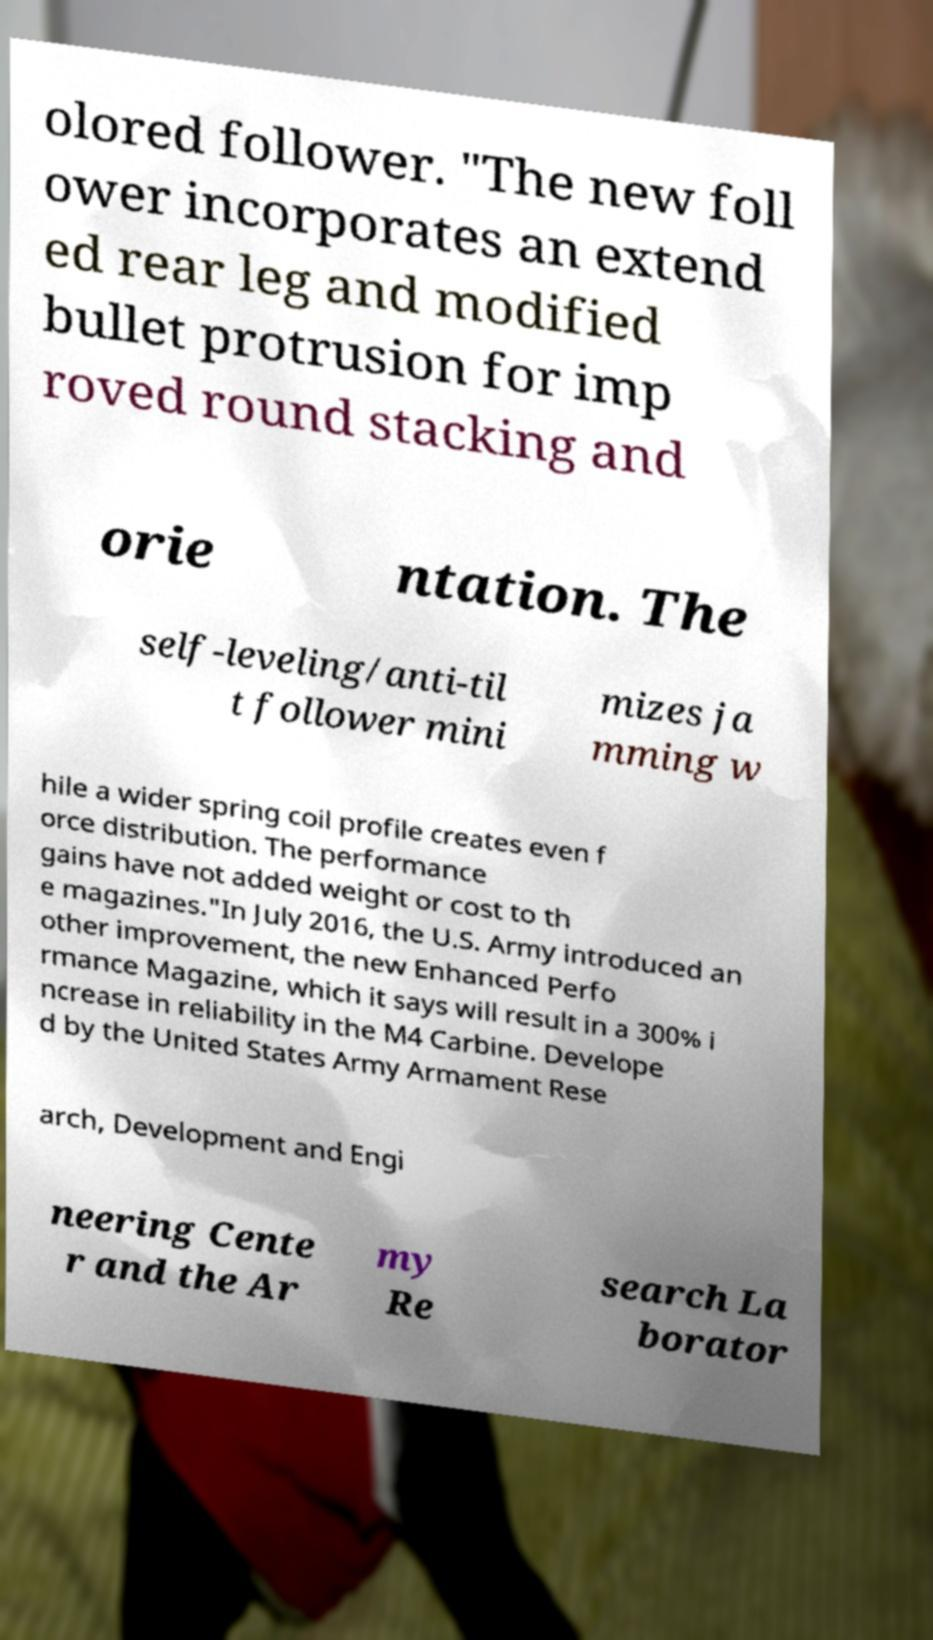Can you read and provide the text displayed in the image?This photo seems to have some interesting text. Can you extract and type it out for me? olored follower. "The new foll ower incorporates an extend ed rear leg and modified bullet protrusion for imp roved round stacking and orie ntation. The self-leveling/anti-til t follower mini mizes ja mming w hile a wider spring coil profile creates even f orce distribution. The performance gains have not added weight or cost to th e magazines."In July 2016, the U.S. Army introduced an other improvement, the new Enhanced Perfo rmance Magazine, which it says will result in a 300% i ncrease in reliability in the M4 Carbine. Develope d by the United States Army Armament Rese arch, Development and Engi neering Cente r and the Ar my Re search La borator 